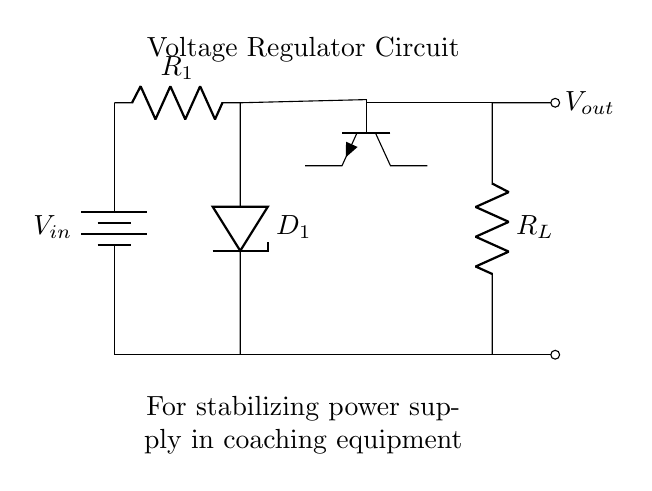What is the function of the Zener diode in this circuit? The Zener diode regulates the output voltage by allowing current to flow in the reverse direction when the input voltage exceeds a certain level, thus stabilizing the output voltage.
Answer: Regulator What type of transistor is used in this circuit? The transistor shown in the circuit diagram is an NPN type, recognized by its three connections: base, collector, and emitter, along with the symbol indicating its configuration.
Answer: NPN What is the role of the resistor R1? Resistor R1 limits the current flowing into the Zener diode, preventing it from exceeding its maximum rated current and ensuring stable operation of the voltage regulation.
Answer: Current limiter What is the significance of the load resistor R_L in the circuit? Load resistor R_L is connected to the output and represents the actual load on the circuit; it helps determine the current flowing in the circuit and impacts the voltage regulation performance.
Answer: Load representation What voltage does the battery supply in this circuit? The battery supplies the input voltage, denoted as V_in, required for the circuit's operation, though the exact value is not specified in the diagram.
Answer: V_in What happens when the input voltage exceeds the Zener voltage? When the input voltage exceeds the Zener voltage, the Zener diode conducts reverse current, maintaining a constant output voltage at the Zener value, which stabilizes the output.
Answer: Current conducts How is the output voltage derived in this regulator circuit? The output voltage is derived from the Zener diode's stable voltage level across R_L, offering a regulated output to the connected load regardless of variations in the input voltage (up to the regulation limit).
Answer: Regulated output 